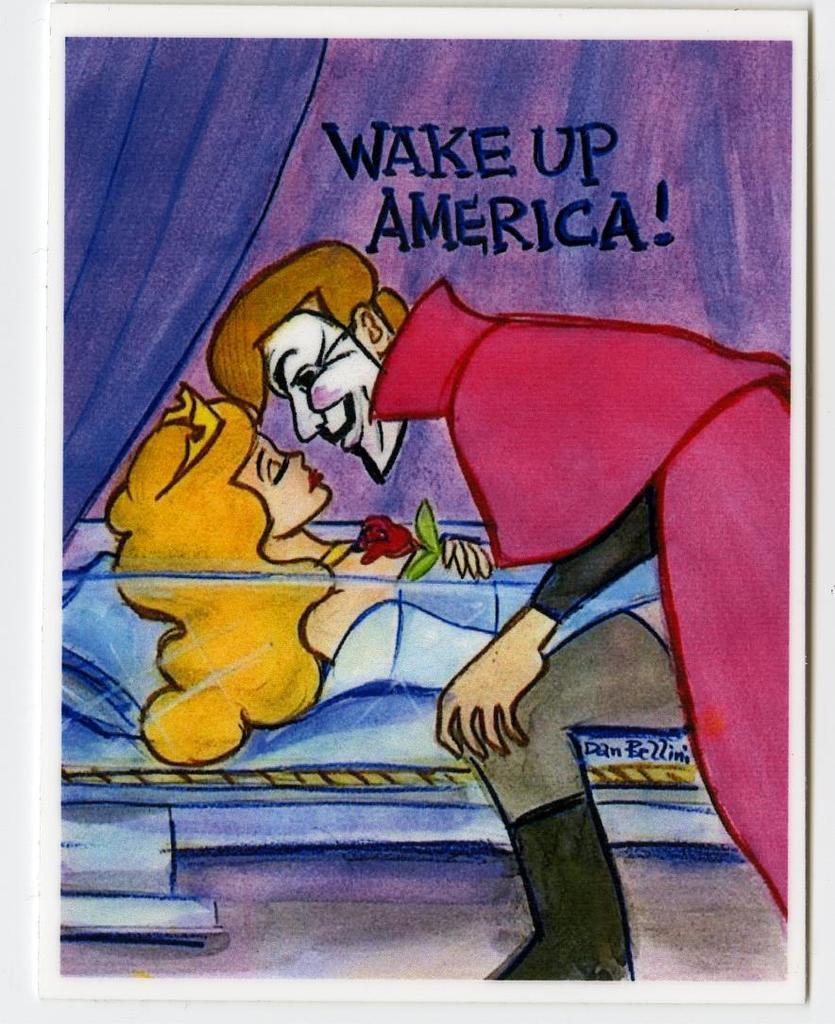Please provide a concise description of this image. In this image there is a painting of a person placed his head near to the woman's face, she is sleeping on the bed, above them there is some text, beside the bed there is a curtain. 